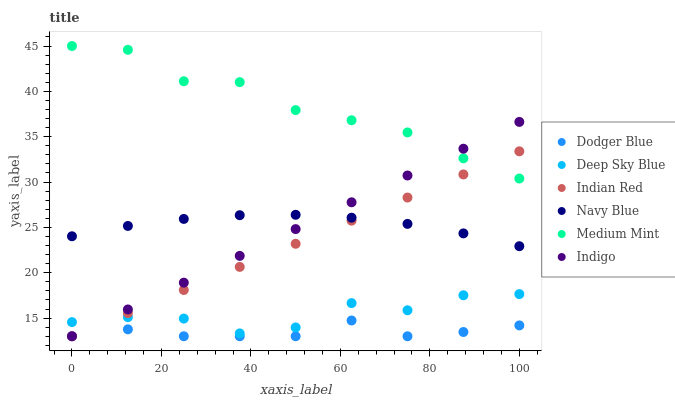Does Dodger Blue have the minimum area under the curve?
Answer yes or no. Yes. Does Medium Mint have the maximum area under the curve?
Answer yes or no. Yes. Does Indigo have the minimum area under the curve?
Answer yes or no. No. Does Indigo have the maximum area under the curve?
Answer yes or no. No. Is Indigo the smoothest?
Answer yes or no. Yes. Is Deep Sky Blue the roughest?
Answer yes or no. Yes. Is Deep Sky Blue the smoothest?
Answer yes or no. No. Is Indigo the roughest?
Answer yes or no. No. Does Indigo have the lowest value?
Answer yes or no. Yes. Does Deep Sky Blue have the lowest value?
Answer yes or no. No. Does Medium Mint have the highest value?
Answer yes or no. Yes. Does Indigo have the highest value?
Answer yes or no. No. Is Deep Sky Blue less than Medium Mint?
Answer yes or no. Yes. Is Navy Blue greater than Deep Sky Blue?
Answer yes or no. Yes. Does Indigo intersect Navy Blue?
Answer yes or no. Yes. Is Indigo less than Navy Blue?
Answer yes or no. No. Is Indigo greater than Navy Blue?
Answer yes or no. No. Does Deep Sky Blue intersect Medium Mint?
Answer yes or no. No. 